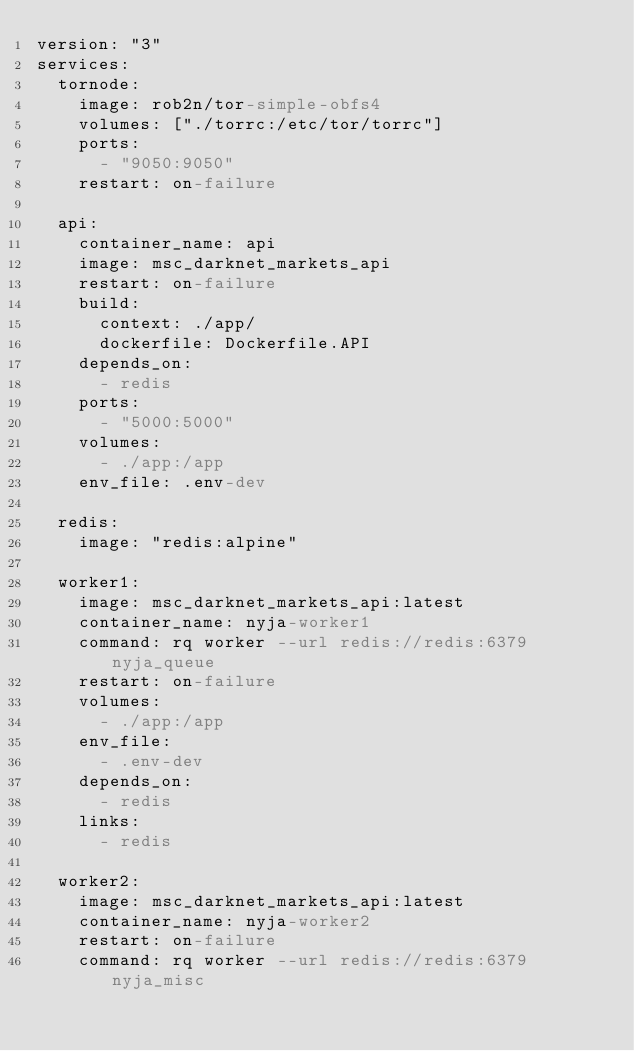<code> <loc_0><loc_0><loc_500><loc_500><_YAML_>version: "3"
services:
  tornode:
    image: rob2n/tor-simple-obfs4
    volumes: ["./torrc:/etc/tor/torrc"]
    ports:
      - "9050:9050"
    restart: on-failure

  api:
    container_name: api
    image: msc_darknet_markets_api
    restart: on-failure
    build:
      context: ./app/
      dockerfile: Dockerfile.API
    depends_on:
      - redis
    ports:
      - "5000:5000"
    volumes:
      - ./app:/app
    env_file: .env-dev

  redis:
    image: "redis:alpine"

  worker1:
    image: msc_darknet_markets_api:latest
    container_name: nyja-worker1
    command: rq worker --url redis://redis:6379 nyja_queue
    restart: on-failure
    volumes:
      - ./app:/app
    env_file:
      - .env-dev
    depends_on:
      - redis
    links:
      - redis

  worker2:
    image: msc_darknet_markets_api:latest
    container_name: nyja-worker2
    restart: on-failure
    command: rq worker --url redis://redis:6379 nyja_misc</code> 